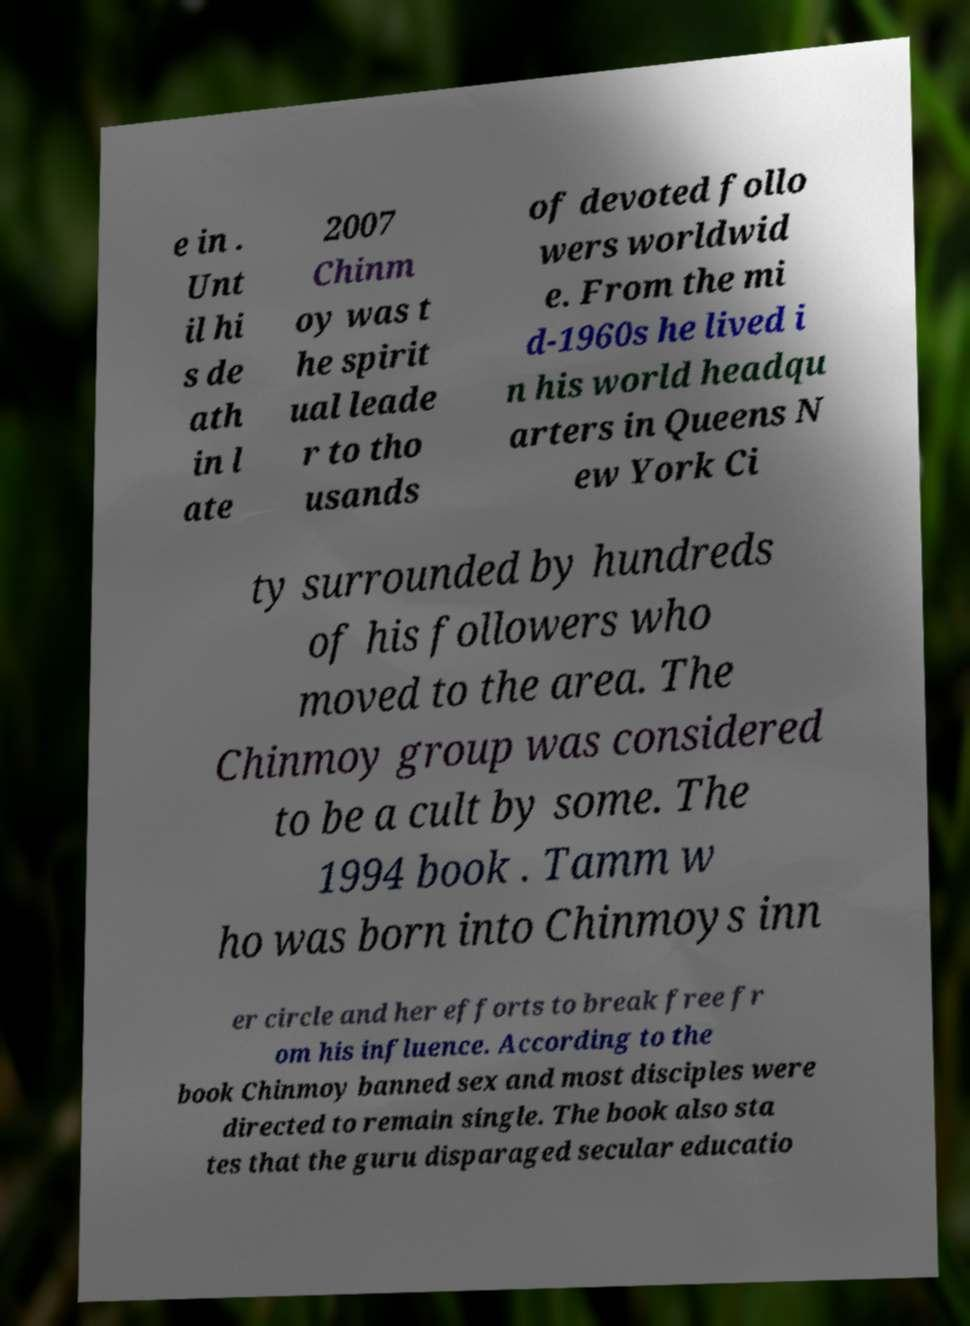Can you accurately transcribe the text from the provided image for me? e in . Unt il hi s de ath in l ate 2007 Chinm oy was t he spirit ual leade r to tho usands of devoted follo wers worldwid e. From the mi d-1960s he lived i n his world headqu arters in Queens N ew York Ci ty surrounded by hundreds of his followers who moved to the area. The Chinmoy group was considered to be a cult by some. The 1994 book . Tamm w ho was born into Chinmoys inn er circle and her efforts to break free fr om his influence. According to the book Chinmoy banned sex and most disciples were directed to remain single. The book also sta tes that the guru disparaged secular educatio 